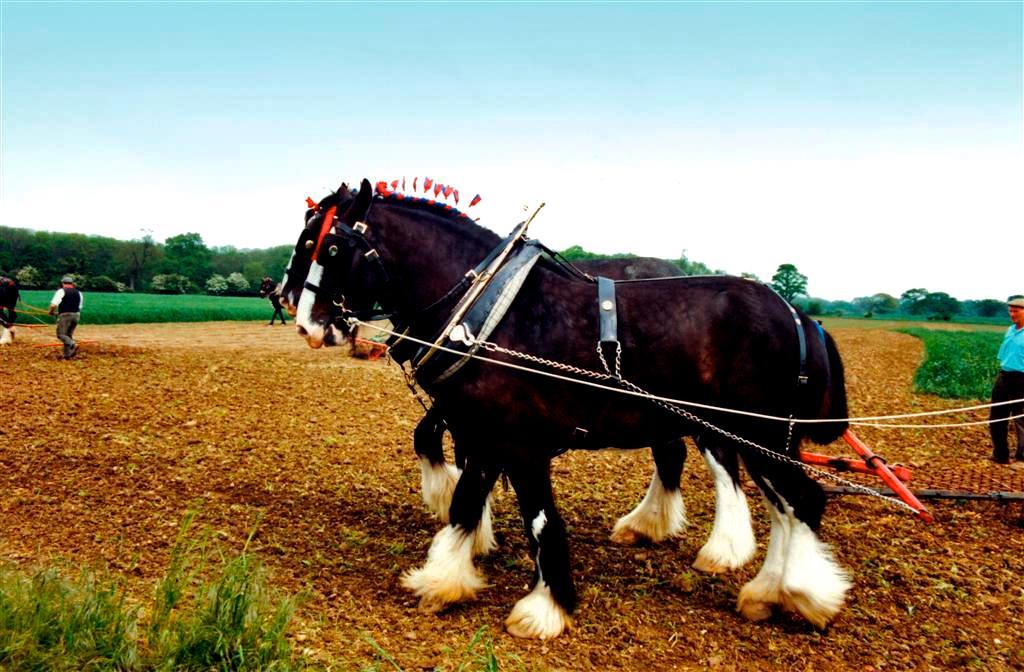Describe this image in one or two sentences. In this image I can see the horses. I can see the chain, rope and the belt to one of the horse. I can see two people with different color dresses. In the background I can see the plants, many trees and the sky. 